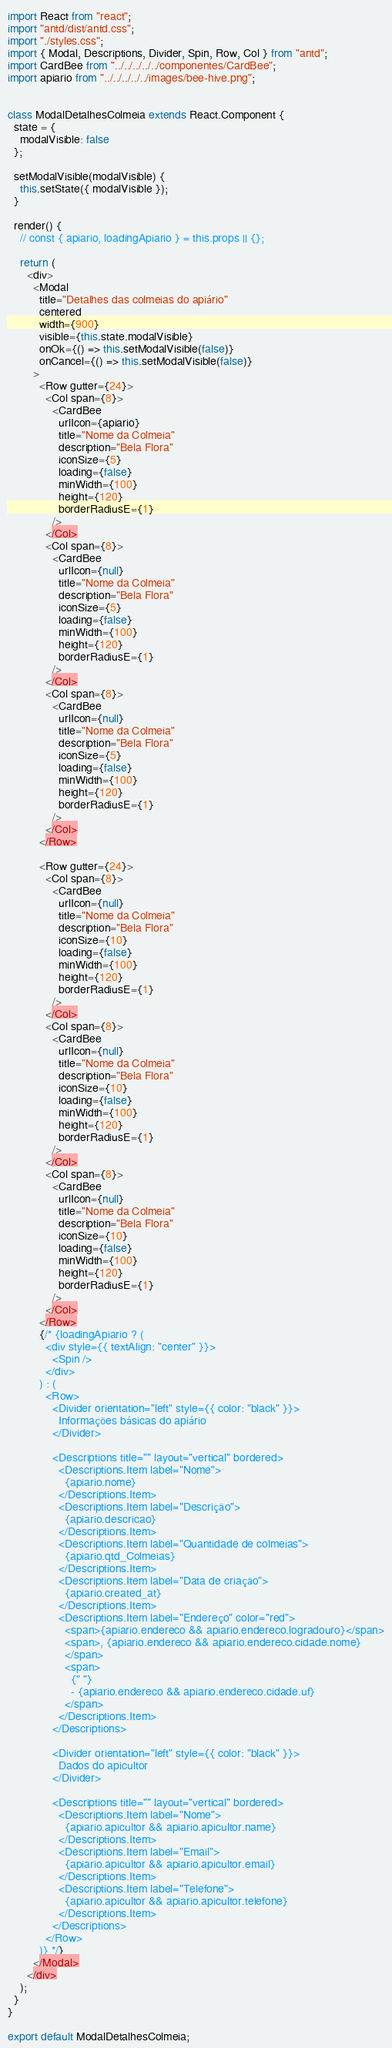<code> <loc_0><loc_0><loc_500><loc_500><_JavaScript_>import React from "react";
import "antd/dist/antd.css";
import "./styles.css";
import { Modal, Descriptions, Divider, Spin, Row, Col } from "antd";
import CardBee from "../../../../../componentes/CardBee";
import apiario from "../../../../../images/bee-hive.png";


class ModalDetalhesColmeia extends React.Component {
  state = {
    modalVisible: false
  };

  setModalVisible(modalVisible) {
    this.setState({ modalVisible });
  }

  render() {
    // const { apiario, loadingApiario } = this.props || {};

    return (
      <div>
        <Modal
          title="Detalhes das colmeias do apiário"
          centered
          width={900}
          visible={this.state.modalVisible}
          onOk={() => this.setModalVisible(false)}
          onCancel={() => this.setModalVisible(false)}
        >
          <Row gutter={24}>
            <Col span={8}>
              <CardBee
                urlIcon={apiario}
                title="Nome da Colmeia"
                description="Bela Flora"
                iconSize={5}
                loading={false}
                minWidth={100}
                height={120}
                borderRadiusE={1}
              />
            </Col>
            <Col span={8}>
              <CardBee
                urlIcon={null}
                title="Nome da Colmeia"
                description="Bela Flora"
                iconSize={5}
                loading={false}
                minWidth={100}
                height={120}
                borderRadiusE={1}
              />
            </Col>
            <Col span={8}>
              <CardBee
                urlIcon={null}
                title="Nome da Colmeia"
                description="Bela Flora"
                iconSize={5}
                loading={false}
                minWidth={100}
                height={120}
                borderRadiusE={1}
              />
            </Col>
          </Row>

          <Row gutter={24}>
            <Col span={8}>
              <CardBee
                urlIcon={null}
                title="Nome da Colmeia"
                description="Bela Flora"
                iconSize={10}
                loading={false}
                minWidth={100}
                height={120}
                borderRadiusE={1}
              />
            </Col>
            <Col span={8}>
              <CardBee
                urlIcon={null}
                title="Nome da Colmeia"
                description="Bela Flora"
                iconSize={10}
                loading={false}
                minWidth={100}
                height={120}
                borderRadiusE={1}
              />
            </Col>
            <Col span={8}>
              <CardBee
                urlIcon={null}
                title="Nome da Colmeia"
                description="Bela Flora"
                iconSize={10}
                loading={false}
                minWidth={100}
                height={120}
                borderRadiusE={1}
              />
            </Col>
          </Row>
          {/* {loadingApiario ? (
            <div style={{ textAlign: "center" }}>
              <Spin />
            </div>
          ) : (
            <Row>
              <Divider orientation="left" style={{ color: "black" }}>
                Informações básicas do apiário
              </Divider>

              <Descriptions title="" layout="vertical" bordered>
                <Descriptions.Item label="Nome">
                  {apiario.nome}
                </Descriptions.Item>
                <Descriptions.Item label="Descrição">
                  {apiario.descricao}
                </Descriptions.Item>
                <Descriptions.Item label="Quantidade de colmeias">
                  {apiario.qtd_Colmeias}
                </Descriptions.Item>
                <Descriptions.Item label="Data de criação">
                  {apiario.created_at}
                </Descriptions.Item>
                <Descriptions.Item label="Endereço" color="red">
                  <span>{apiario.endereco && apiario.endereco.logradouro}</span>
                  <span>, {apiario.endereco && apiario.endereco.cidade.nome}
                  </span>
                  <span>
                    {" "}
                    - {apiario.endereco && apiario.endereco.cidade.uf}
                  </span>
                </Descriptions.Item>
              </Descriptions>

              <Divider orientation="left" style={{ color: "black" }}>
                Dados do apicultor
              </Divider>

              <Descriptions title="" layout="vertical" bordered>
                <Descriptions.Item label="Nome">
                  {apiario.apicultor && apiario.apicultor.name}
                </Descriptions.Item>
                <Descriptions.Item label="Email">
                  {apiario.apicultor && apiario.apicultor.email}
                </Descriptions.Item>
                <Descriptions.Item label="Telefone">
                  {apiario.apicultor && apiario.apicultor.telefone}
                </Descriptions.Item>
              </Descriptions>
            </Row>
          )} */}
        </Modal>
      </div>
    );
  }
}

export default ModalDetalhesColmeia;
</code> 